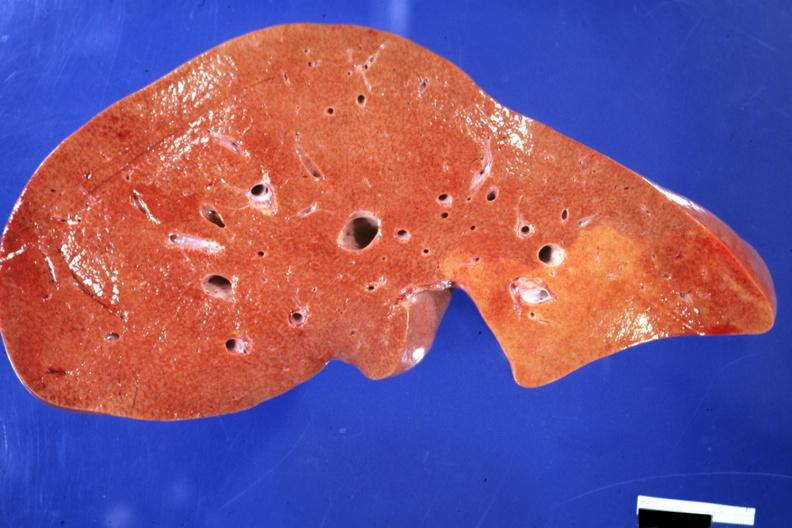s optic nerve present?
Answer the question using a single word or phrase. No 